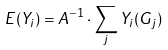<formula> <loc_0><loc_0><loc_500><loc_500>E ( Y _ { i } ) = A ^ { - 1 } \cdot \sum _ { j } Y _ { i } ( G _ { j } )</formula> 